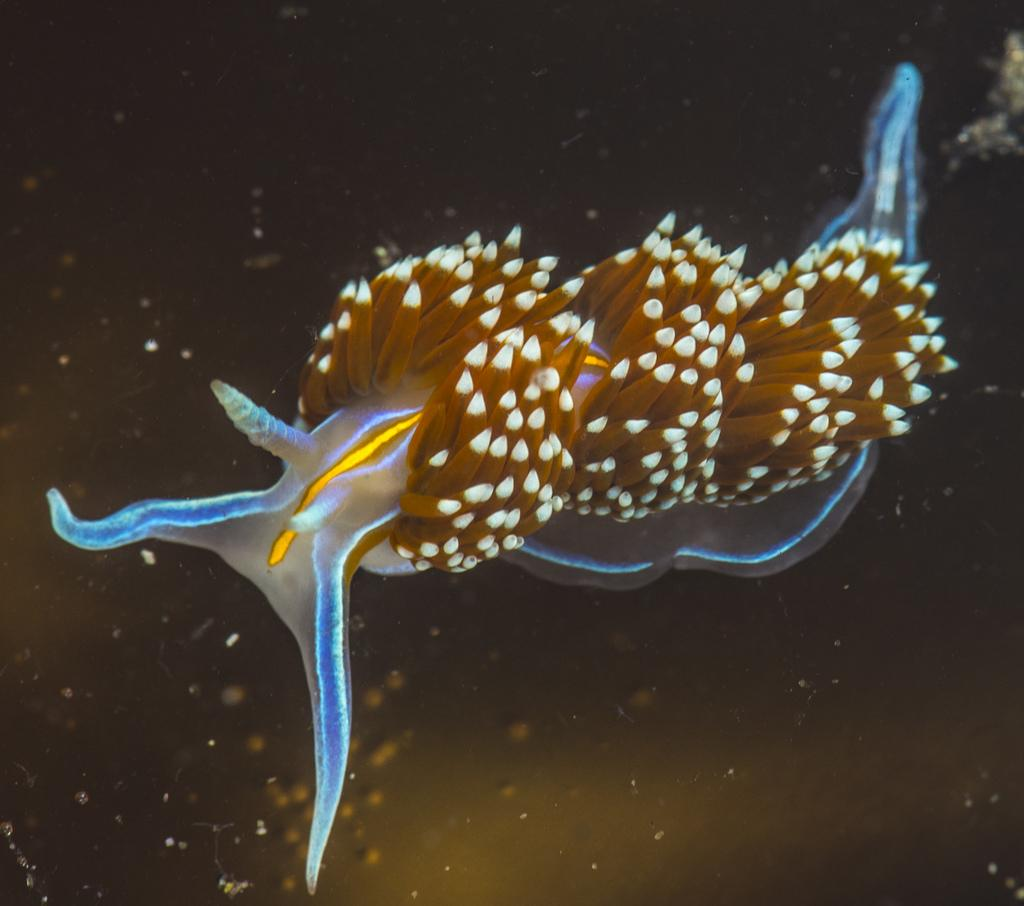What type of creature can be seen in the image? There is an underwater creature in the image. What type of zipper can be seen on the pigs in the image? There are no pigs or zippers present in the image; it features an underwater creature. 